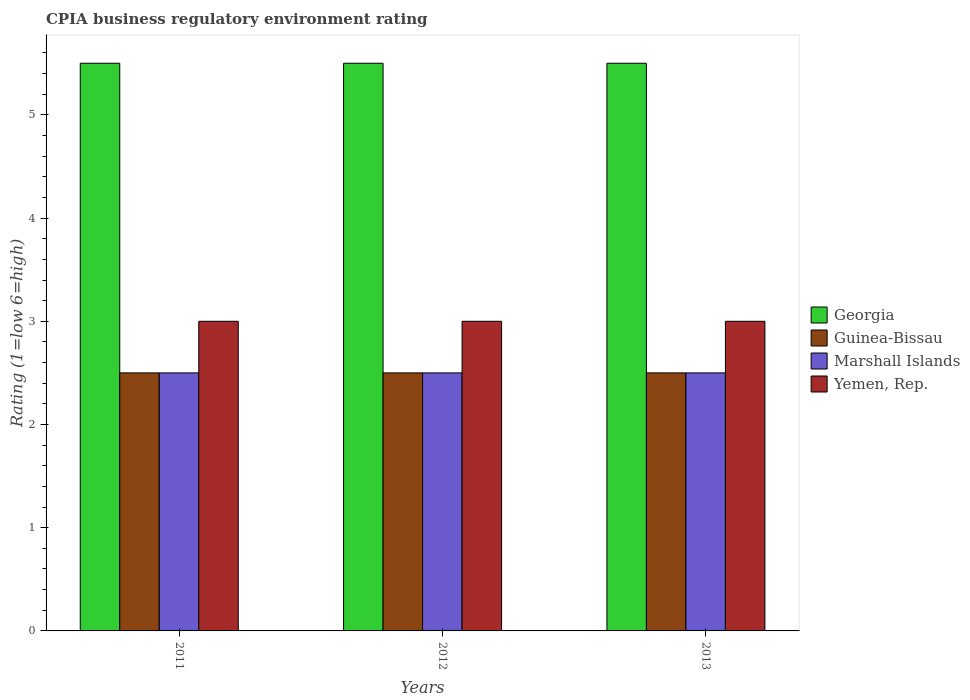How many different coloured bars are there?
Your response must be concise. 4. Are the number of bars per tick equal to the number of legend labels?
Provide a short and direct response. Yes. Are the number of bars on each tick of the X-axis equal?
Provide a succinct answer. Yes. How many bars are there on the 1st tick from the left?
Your response must be concise. 4. How many bars are there on the 2nd tick from the right?
Provide a succinct answer. 4. What is the CPIA rating in Georgia in 2012?
Your response must be concise. 5.5. In which year was the CPIA rating in Marshall Islands maximum?
Keep it short and to the point. 2011. In which year was the CPIA rating in Yemen, Rep. minimum?
Your answer should be very brief. 2011. What is the difference between the CPIA rating in Guinea-Bissau in 2012 and the CPIA rating in Georgia in 2013?
Make the answer very short. -3. What is the average CPIA rating in Guinea-Bissau per year?
Your response must be concise. 2.5. In the year 2013, what is the difference between the CPIA rating in Georgia and CPIA rating in Yemen, Rep.?
Provide a short and direct response. 2.5. In how many years, is the CPIA rating in Guinea-Bissau greater than 2?
Provide a short and direct response. 3. What is the ratio of the CPIA rating in Georgia in 2011 to that in 2013?
Make the answer very short. 1. Is the difference between the CPIA rating in Georgia in 2011 and 2012 greater than the difference between the CPIA rating in Yemen, Rep. in 2011 and 2012?
Provide a short and direct response. No. What is the difference between the highest and the lowest CPIA rating in Marshall Islands?
Provide a succinct answer. 0. In how many years, is the CPIA rating in Guinea-Bissau greater than the average CPIA rating in Guinea-Bissau taken over all years?
Give a very brief answer. 0. Is the sum of the CPIA rating in Georgia in 2012 and 2013 greater than the maximum CPIA rating in Guinea-Bissau across all years?
Keep it short and to the point. Yes. What does the 3rd bar from the left in 2011 represents?
Provide a short and direct response. Marshall Islands. What does the 1st bar from the right in 2013 represents?
Offer a terse response. Yemen, Rep. Is it the case that in every year, the sum of the CPIA rating in Yemen, Rep. and CPIA rating in Marshall Islands is greater than the CPIA rating in Guinea-Bissau?
Make the answer very short. Yes. Are all the bars in the graph horizontal?
Your answer should be compact. No. How many years are there in the graph?
Your answer should be very brief. 3. Does the graph contain grids?
Make the answer very short. No. How many legend labels are there?
Provide a short and direct response. 4. What is the title of the graph?
Keep it short and to the point. CPIA business regulatory environment rating. Does "Bhutan" appear as one of the legend labels in the graph?
Give a very brief answer. No. What is the label or title of the X-axis?
Your answer should be very brief. Years. What is the Rating (1=low 6=high) in Georgia in 2011?
Your answer should be compact. 5.5. What is the Rating (1=low 6=high) in Marshall Islands in 2011?
Your response must be concise. 2.5. What is the Rating (1=low 6=high) of Yemen, Rep. in 2011?
Give a very brief answer. 3. What is the Rating (1=low 6=high) in Guinea-Bissau in 2012?
Make the answer very short. 2.5. What is the Rating (1=low 6=high) in Marshall Islands in 2012?
Offer a very short reply. 2.5. What is the Rating (1=low 6=high) in Yemen, Rep. in 2012?
Provide a short and direct response. 3. What is the Rating (1=low 6=high) of Georgia in 2013?
Offer a terse response. 5.5. What is the Rating (1=low 6=high) in Marshall Islands in 2013?
Your response must be concise. 2.5. Across all years, what is the maximum Rating (1=low 6=high) in Georgia?
Your response must be concise. 5.5. Across all years, what is the minimum Rating (1=low 6=high) in Guinea-Bissau?
Provide a succinct answer. 2.5. What is the total Rating (1=low 6=high) of Georgia in the graph?
Ensure brevity in your answer.  16.5. What is the total Rating (1=low 6=high) of Guinea-Bissau in the graph?
Ensure brevity in your answer.  7.5. What is the total Rating (1=low 6=high) of Yemen, Rep. in the graph?
Keep it short and to the point. 9. What is the difference between the Rating (1=low 6=high) in Georgia in 2011 and that in 2012?
Your answer should be very brief. 0. What is the difference between the Rating (1=low 6=high) in Yemen, Rep. in 2011 and that in 2012?
Keep it short and to the point. 0. What is the difference between the Rating (1=low 6=high) of Marshall Islands in 2011 and that in 2013?
Ensure brevity in your answer.  0. What is the difference between the Rating (1=low 6=high) in Yemen, Rep. in 2011 and that in 2013?
Give a very brief answer. 0. What is the difference between the Rating (1=low 6=high) of Georgia in 2012 and that in 2013?
Your answer should be compact. 0. What is the difference between the Rating (1=low 6=high) in Marshall Islands in 2012 and that in 2013?
Your answer should be very brief. 0. What is the difference between the Rating (1=low 6=high) of Georgia in 2011 and the Rating (1=low 6=high) of Marshall Islands in 2012?
Offer a terse response. 3. What is the difference between the Rating (1=low 6=high) of Guinea-Bissau in 2011 and the Rating (1=low 6=high) of Marshall Islands in 2012?
Offer a very short reply. 0. What is the difference between the Rating (1=low 6=high) of Marshall Islands in 2011 and the Rating (1=low 6=high) of Yemen, Rep. in 2012?
Ensure brevity in your answer.  -0.5. What is the difference between the Rating (1=low 6=high) of Georgia in 2011 and the Rating (1=low 6=high) of Guinea-Bissau in 2013?
Your response must be concise. 3. What is the difference between the Rating (1=low 6=high) of Georgia in 2011 and the Rating (1=low 6=high) of Marshall Islands in 2013?
Offer a terse response. 3. What is the difference between the Rating (1=low 6=high) of Georgia in 2011 and the Rating (1=low 6=high) of Yemen, Rep. in 2013?
Provide a succinct answer. 2.5. What is the difference between the Rating (1=low 6=high) of Guinea-Bissau in 2011 and the Rating (1=low 6=high) of Yemen, Rep. in 2013?
Ensure brevity in your answer.  -0.5. What is the difference between the Rating (1=low 6=high) in Georgia in 2012 and the Rating (1=low 6=high) in Guinea-Bissau in 2013?
Provide a short and direct response. 3. What is the difference between the Rating (1=low 6=high) in Georgia in 2012 and the Rating (1=low 6=high) in Marshall Islands in 2013?
Offer a very short reply. 3. What is the difference between the Rating (1=low 6=high) of Georgia in 2012 and the Rating (1=low 6=high) of Yemen, Rep. in 2013?
Give a very brief answer. 2.5. What is the difference between the Rating (1=low 6=high) in Guinea-Bissau in 2012 and the Rating (1=low 6=high) in Yemen, Rep. in 2013?
Offer a terse response. -0.5. In the year 2011, what is the difference between the Rating (1=low 6=high) in Georgia and Rating (1=low 6=high) in Yemen, Rep.?
Give a very brief answer. 2.5. In the year 2011, what is the difference between the Rating (1=low 6=high) of Guinea-Bissau and Rating (1=low 6=high) of Marshall Islands?
Provide a succinct answer. 0. In the year 2011, what is the difference between the Rating (1=low 6=high) of Marshall Islands and Rating (1=low 6=high) of Yemen, Rep.?
Offer a terse response. -0.5. In the year 2012, what is the difference between the Rating (1=low 6=high) in Georgia and Rating (1=low 6=high) in Guinea-Bissau?
Provide a succinct answer. 3. In the year 2012, what is the difference between the Rating (1=low 6=high) of Marshall Islands and Rating (1=low 6=high) of Yemen, Rep.?
Keep it short and to the point. -0.5. In the year 2013, what is the difference between the Rating (1=low 6=high) of Georgia and Rating (1=low 6=high) of Marshall Islands?
Give a very brief answer. 3. In the year 2013, what is the difference between the Rating (1=low 6=high) of Guinea-Bissau and Rating (1=low 6=high) of Marshall Islands?
Offer a terse response. 0. What is the ratio of the Rating (1=low 6=high) in Georgia in 2011 to that in 2012?
Give a very brief answer. 1. What is the ratio of the Rating (1=low 6=high) of Marshall Islands in 2011 to that in 2012?
Provide a short and direct response. 1. What is the ratio of the Rating (1=low 6=high) of Yemen, Rep. in 2011 to that in 2012?
Your response must be concise. 1. What is the ratio of the Rating (1=low 6=high) in Georgia in 2011 to that in 2013?
Ensure brevity in your answer.  1. What is the ratio of the Rating (1=low 6=high) in Marshall Islands in 2011 to that in 2013?
Provide a succinct answer. 1. What is the ratio of the Rating (1=low 6=high) of Yemen, Rep. in 2011 to that in 2013?
Offer a very short reply. 1. What is the ratio of the Rating (1=low 6=high) in Guinea-Bissau in 2012 to that in 2013?
Provide a short and direct response. 1. What is the ratio of the Rating (1=low 6=high) in Marshall Islands in 2012 to that in 2013?
Your answer should be very brief. 1. What is the ratio of the Rating (1=low 6=high) in Yemen, Rep. in 2012 to that in 2013?
Provide a succinct answer. 1. What is the difference between the highest and the second highest Rating (1=low 6=high) in Georgia?
Give a very brief answer. 0. What is the difference between the highest and the second highest Rating (1=low 6=high) in Guinea-Bissau?
Provide a short and direct response. 0. What is the difference between the highest and the second highest Rating (1=low 6=high) of Marshall Islands?
Provide a succinct answer. 0. What is the difference between the highest and the second highest Rating (1=low 6=high) of Yemen, Rep.?
Provide a short and direct response. 0. What is the difference between the highest and the lowest Rating (1=low 6=high) in Georgia?
Offer a terse response. 0. What is the difference between the highest and the lowest Rating (1=low 6=high) in Marshall Islands?
Offer a terse response. 0. What is the difference between the highest and the lowest Rating (1=low 6=high) of Yemen, Rep.?
Your answer should be very brief. 0. 